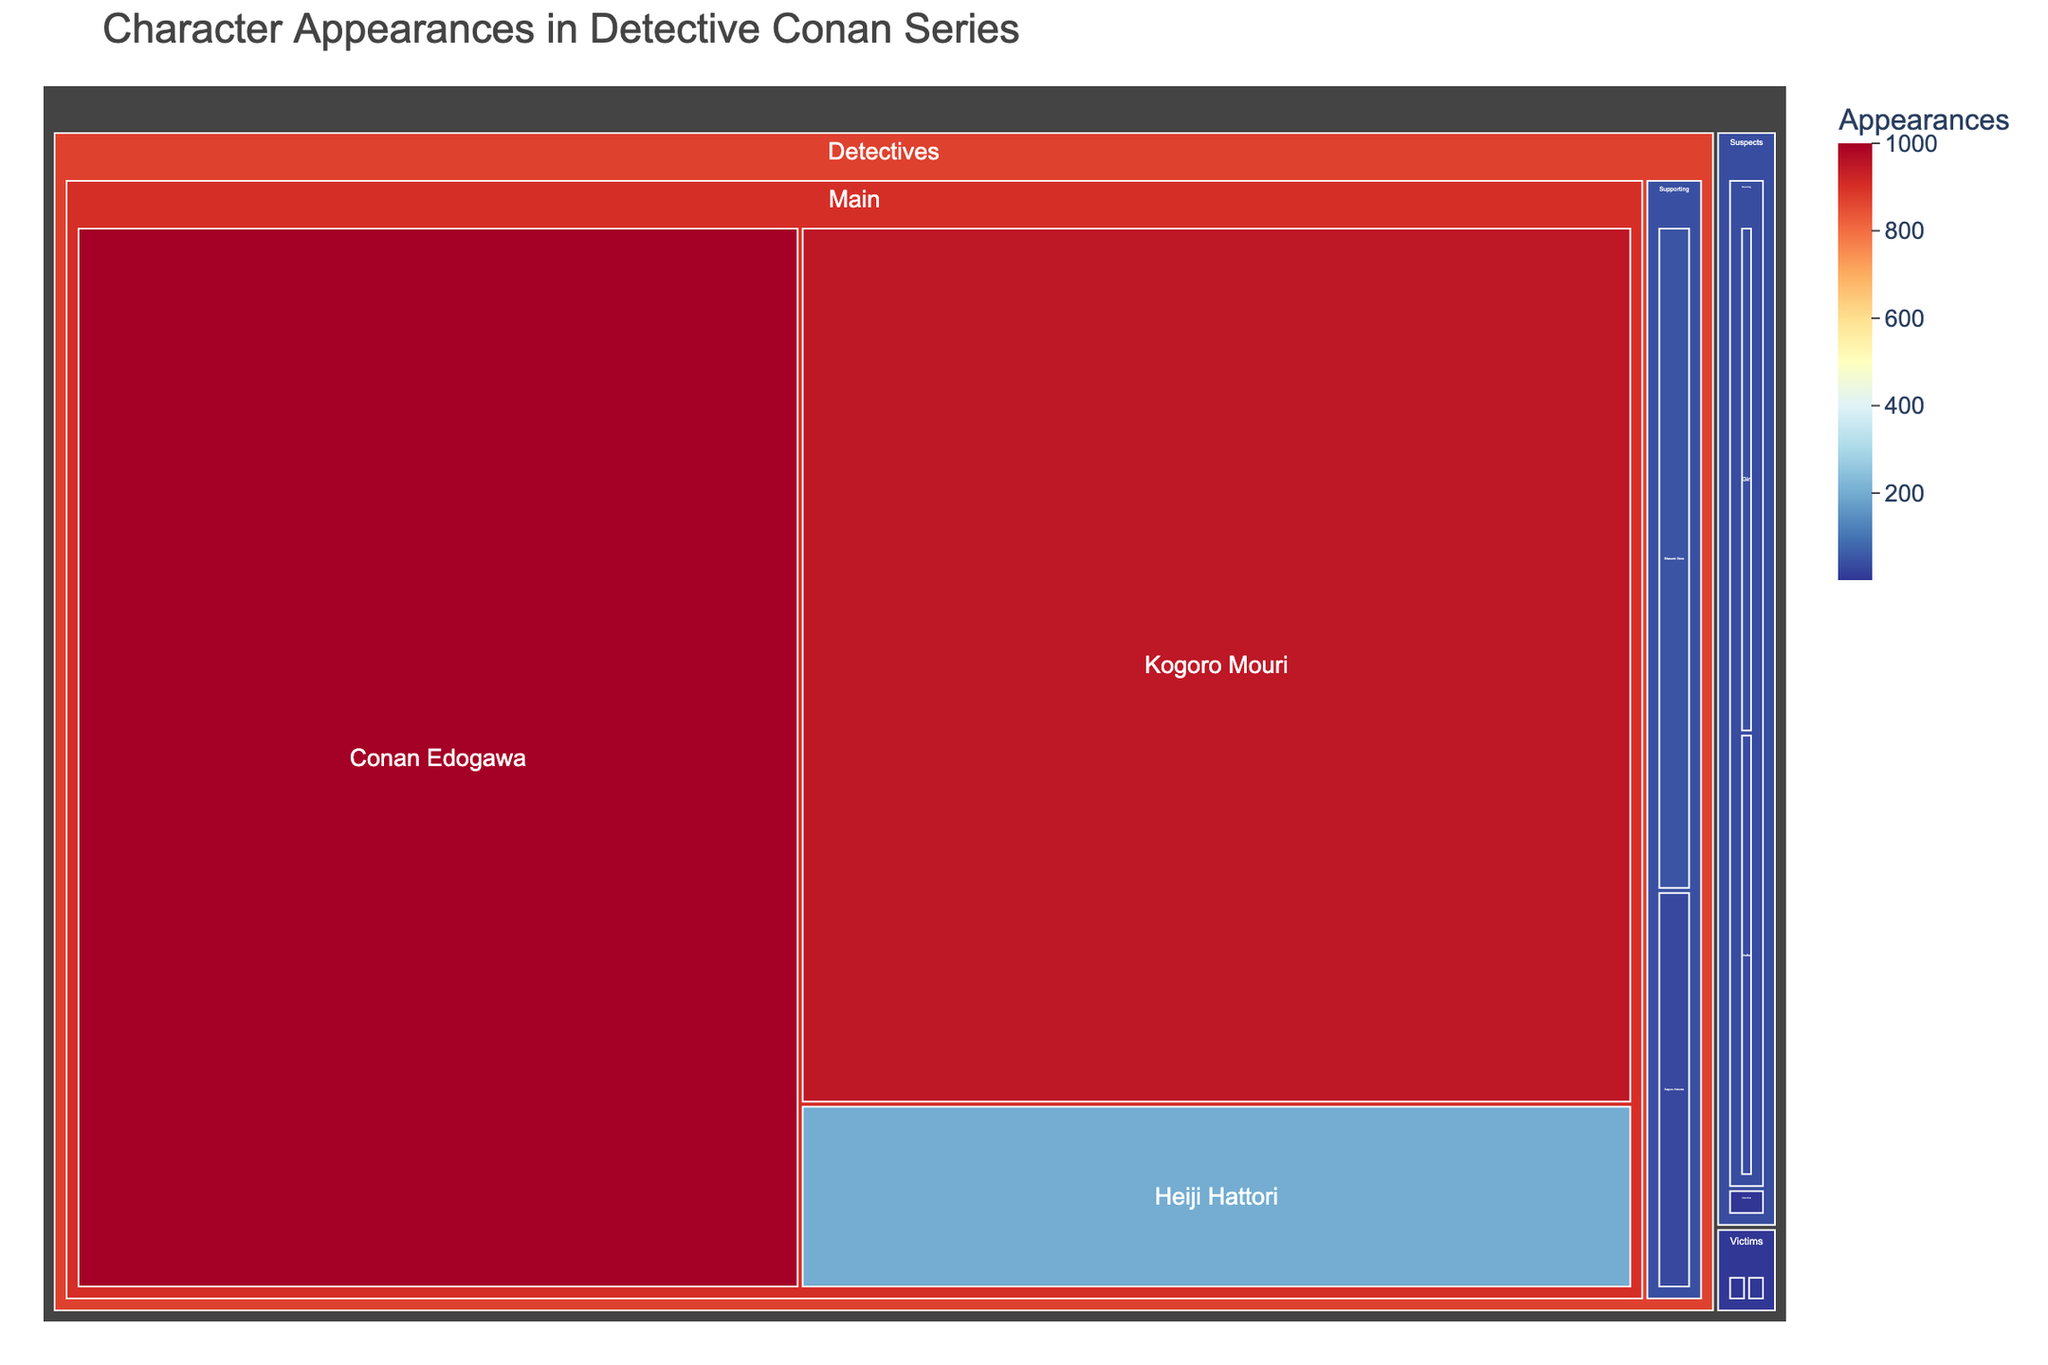What is the main category with the most appearances? By looking at the size of the rectangles, the "Detectives" category has the largest area, indicating the highest number of appearances. The data in the plot confirms this.
Answer: Detectives How many appearances does Conan Edogawa have? Conan Edogawa is in the Detectives category and has a dedicated rectangle with the appearance count visible. It shows 1000 appearances.
Answer: 1000 Which character has the fewest appearances, and how many do they have? The smallest rectangles in the treemap pertain to characters with the least appearances. There are multiple characters with 1 appearance: Yuki Ogawa, Takeshi Noma, Kenzo Masuyama, Reiko Akiba, and Hideomi Nagato.
Answer: 1 How many more appearances does Kogoro Mouri have compared to Heiji Hattori? The treemap shows Kogoro Mouri with 950 appearances and Heiji Hattori with 200 appearances. The difference is 950 - 200 = 750.
Answer: 750 How many characters are there in the recurring victim subcategory, and who are they? By looking at the different segments under the Victims category, there is only one recurring victim, represented by a small square: Akemi Miyano with 3 appearances.
Answer: 1, Akemi Miyano What is the percentage of appearances by the main detectives compared to the total detective appearances? The appearances for main detectives are Conan Edogawa (1000), Kogoro Mouri (950), and Heiji Hattori (200), totaling 2150. The total for all detectives is 2150 (main) + 30 (Saguru Hakuba) + 50 (Masumi Sera) = 2230. The percentage is (2150/2230) * 100 ≈ 96.4%.
Answer: ≈ 96.4% How many characters in the suspects category have more than 30 appearances? In the Suspects category, Gin (40) and Vodka (35) are represented as rectangles. Both have more than 30 appearances.
Answer: 2 Which subcategory within the Detectives category has the highest number of appearances? The Detectives category is divided into Main and Supporting subcategories. The Main subcategory has a total of 2150 appearances (1000+950+200), while Supporting has 80 (30+50). Therefore, Main has the highest appearances.
Answer: Main Who has the most appearances among the supporting detectives? In the Supporting subcategory of Detectives, there are two characters: Saguru Hakuba with 30 appearances and Masumi Sera with 50 appearances. Masumi Sera has the most.
Answer: Masumi Sera Which category has more total appearances, Suspects, or Victims? Summing up the appearances in Suspects and Victims categories - Suspects: (40+35+1+1) = 77, Victims: (3+1+1+1) = 6. Suspects have more total appearances.
Answer: Suspects 